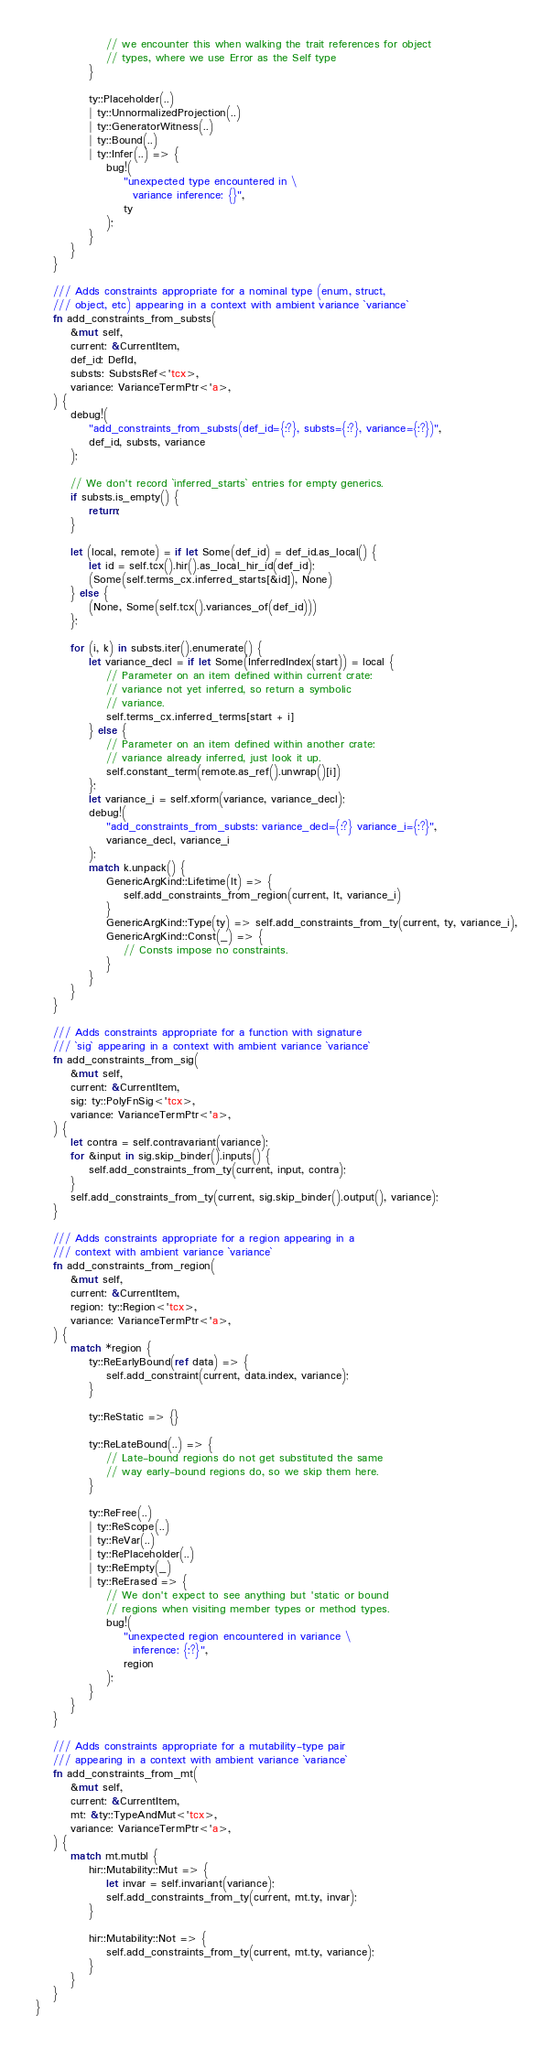<code> <loc_0><loc_0><loc_500><loc_500><_Rust_>                // we encounter this when walking the trait references for object
                // types, where we use Error as the Self type
            }

            ty::Placeholder(..)
            | ty::UnnormalizedProjection(..)
            | ty::GeneratorWitness(..)
            | ty::Bound(..)
            | ty::Infer(..) => {
                bug!(
                    "unexpected type encountered in \
                      variance inference: {}",
                    ty
                );
            }
        }
    }

    /// Adds constraints appropriate for a nominal type (enum, struct,
    /// object, etc) appearing in a context with ambient variance `variance`
    fn add_constraints_from_substs(
        &mut self,
        current: &CurrentItem,
        def_id: DefId,
        substs: SubstsRef<'tcx>,
        variance: VarianceTermPtr<'a>,
    ) {
        debug!(
            "add_constraints_from_substs(def_id={:?}, substs={:?}, variance={:?})",
            def_id, substs, variance
        );

        // We don't record `inferred_starts` entries for empty generics.
        if substs.is_empty() {
            return;
        }

        let (local, remote) = if let Some(def_id) = def_id.as_local() {
            let id = self.tcx().hir().as_local_hir_id(def_id);
            (Some(self.terms_cx.inferred_starts[&id]), None)
        } else {
            (None, Some(self.tcx().variances_of(def_id)))
        };

        for (i, k) in substs.iter().enumerate() {
            let variance_decl = if let Some(InferredIndex(start)) = local {
                // Parameter on an item defined within current crate:
                // variance not yet inferred, so return a symbolic
                // variance.
                self.terms_cx.inferred_terms[start + i]
            } else {
                // Parameter on an item defined within another crate:
                // variance already inferred, just look it up.
                self.constant_term(remote.as_ref().unwrap()[i])
            };
            let variance_i = self.xform(variance, variance_decl);
            debug!(
                "add_constraints_from_substs: variance_decl={:?} variance_i={:?}",
                variance_decl, variance_i
            );
            match k.unpack() {
                GenericArgKind::Lifetime(lt) => {
                    self.add_constraints_from_region(current, lt, variance_i)
                }
                GenericArgKind::Type(ty) => self.add_constraints_from_ty(current, ty, variance_i),
                GenericArgKind::Const(_) => {
                    // Consts impose no constraints.
                }
            }
        }
    }

    /// Adds constraints appropriate for a function with signature
    /// `sig` appearing in a context with ambient variance `variance`
    fn add_constraints_from_sig(
        &mut self,
        current: &CurrentItem,
        sig: ty::PolyFnSig<'tcx>,
        variance: VarianceTermPtr<'a>,
    ) {
        let contra = self.contravariant(variance);
        for &input in sig.skip_binder().inputs() {
            self.add_constraints_from_ty(current, input, contra);
        }
        self.add_constraints_from_ty(current, sig.skip_binder().output(), variance);
    }

    /// Adds constraints appropriate for a region appearing in a
    /// context with ambient variance `variance`
    fn add_constraints_from_region(
        &mut self,
        current: &CurrentItem,
        region: ty::Region<'tcx>,
        variance: VarianceTermPtr<'a>,
    ) {
        match *region {
            ty::ReEarlyBound(ref data) => {
                self.add_constraint(current, data.index, variance);
            }

            ty::ReStatic => {}

            ty::ReLateBound(..) => {
                // Late-bound regions do not get substituted the same
                // way early-bound regions do, so we skip them here.
            }

            ty::ReFree(..)
            | ty::ReScope(..)
            | ty::ReVar(..)
            | ty::RePlaceholder(..)
            | ty::ReEmpty(_)
            | ty::ReErased => {
                // We don't expect to see anything but 'static or bound
                // regions when visiting member types or method types.
                bug!(
                    "unexpected region encountered in variance \
                      inference: {:?}",
                    region
                );
            }
        }
    }

    /// Adds constraints appropriate for a mutability-type pair
    /// appearing in a context with ambient variance `variance`
    fn add_constraints_from_mt(
        &mut self,
        current: &CurrentItem,
        mt: &ty::TypeAndMut<'tcx>,
        variance: VarianceTermPtr<'a>,
    ) {
        match mt.mutbl {
            hir::Mutability::Mut => {
                let invar = self.invariant(variance);
                self.add_constraints_from_ty(current, mt.ty, invar);
            }

            hir::Mutability::Not => {
                self.add_constraints_from_ty(current, mt.ty, variance);
            }
        }
    }
}
</code> 